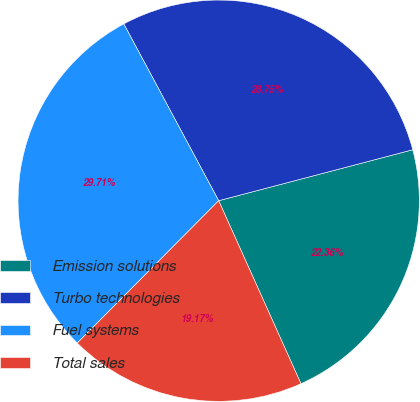Convert chart. <chart><loc_0><loc_0><loc_500><loc_500><pie_chart><fcel>Emission solutions<fcel>Turbo technologies<fcel>Fuel systems<fcel>Total sales<nl><fcel>22.36%<fcel>28.75%<fcel>29.71%<fcel>19.17%<nl></chart> 